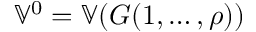<formula> <loc_0><loc_0><loc_500><loc_500>\mathbb { V } ^ { 0 } = \mathbb { V } ( G ( 1 , \dots , \rho ) )</formula> 